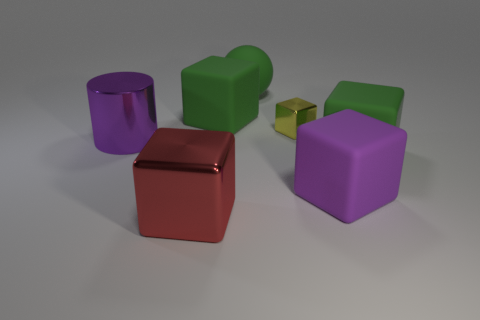What number of other cylinders are the same color as the big cylinder?
Your answer should be very brief. 0. What color is the other large metal thing that is the same shape as the yellow thing?
Your response must be concise. Red. Do the red block and the green ball have the same size?
Your answer should be compact. Yes. Is the number of metallic cylinders in front of the red thing the same as the number of large matte things to the right of the purple rubber cube?
Your response must be concise. No. Is there a red rubber thing?
Offer a very short reply. No. The purple rubber object that is the same shape as the large red metal object is what size?
Ensure brevity in your answer.  Large. There is a green matte block that is in front of the purple shiny object; what is its size?
Ensure brevity in your answer.  Large. Are there more rubber objects that are behind the purple matte block than small yellow cubes?
Provide a short and direct response. Yes. What is the shape of the big purple shiny thing?
Ensure brevity in your answer.  Cylinder. Does the big rubber block that is behind the big purple cylinder have the same color as the big metallic thing behind the big shiny block?
Keep it short and to the point. No. 